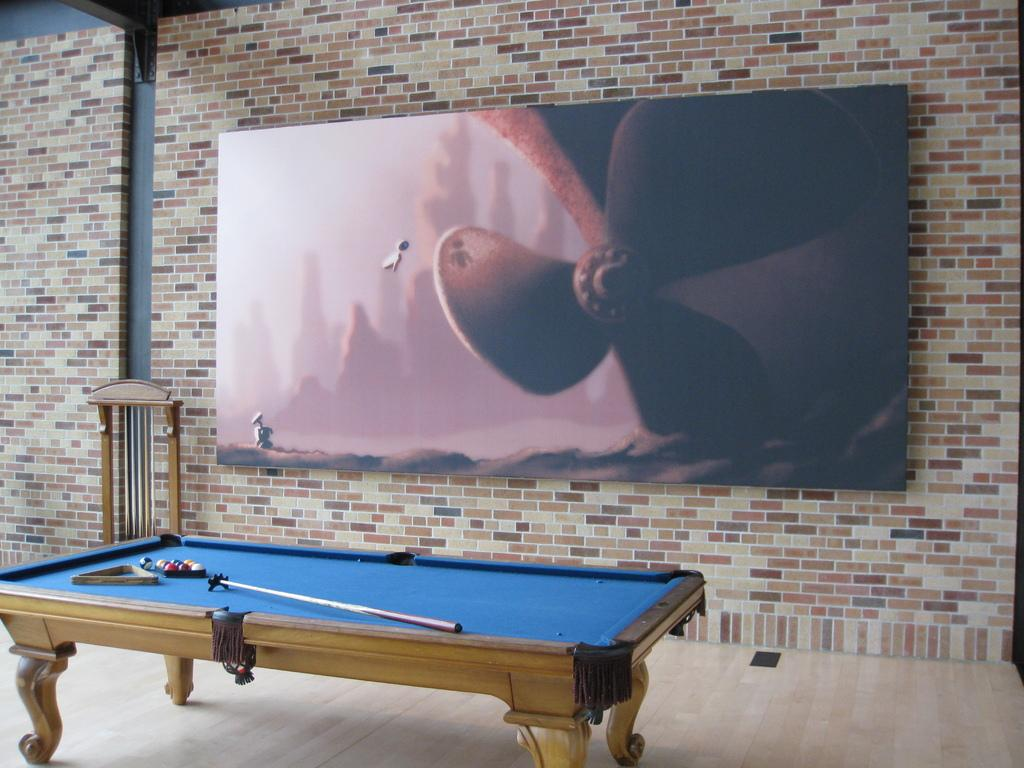What is hanging on the wall in the image? There is a poster on the wall. What type of table is in the image? There is a snooker table in the image. What is on top of the snooker table? There are balls on the snooker table. What is used to hit the balls in the game of snooker? There is a stick (cue) for playing snooker. What type of hammer is used to play the drums in the image? There are no drums or hammers present in the image. What country is depicted on the poster in the image? The provided facts do not mention any country being depicted on the poster. 